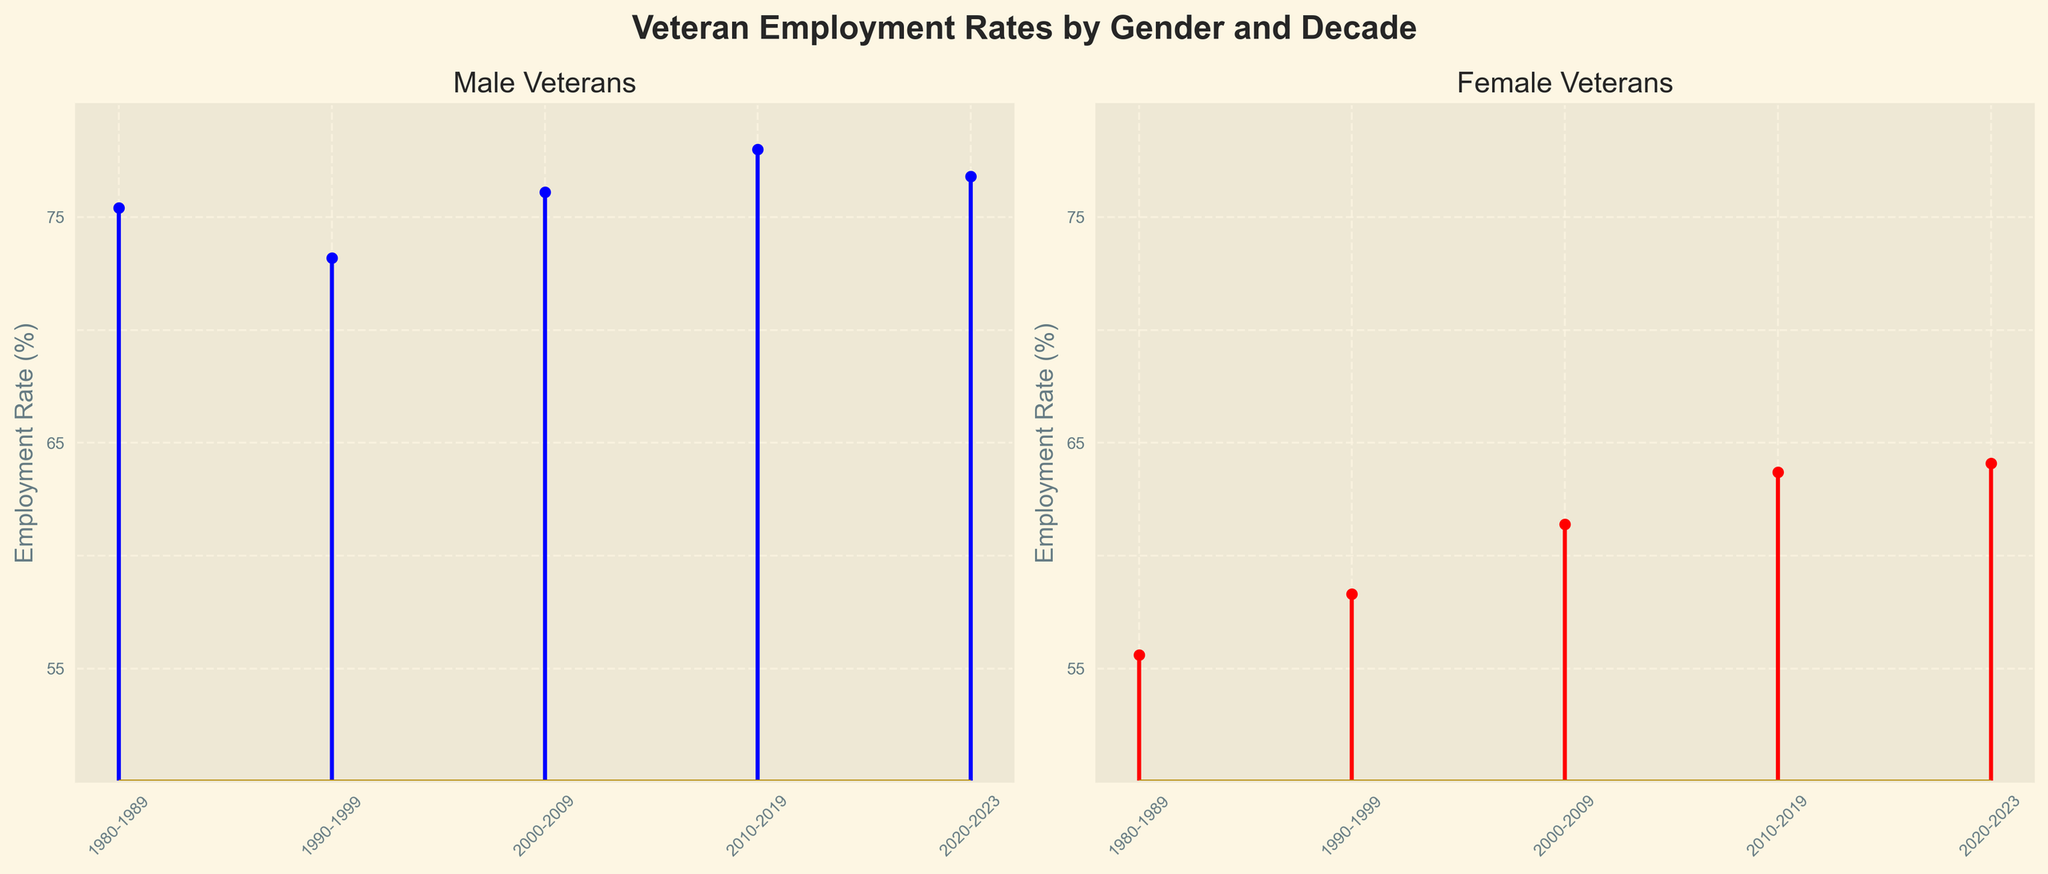What is the title of the figure? The title of the figure is written at the very top and provides a description of the figure.
Answer: Veteran Employment Rates by Gender and Decade What is the employment rate for male veterans in the 2000-2009 decade? Locate the stem plot for male veterans and identify the stem that corresponds to the 2000-2009 decade. The marker indicates the employment rate.
Answer: 76.1% Are female veterans' employment rates higher or lower in the 2020-2023 period compared to the 1980-1989 period? Compare the markers on the female veterans' stem plot for the periods 2020-2023 and 1980-1989.
Answer: Higher How has the employment rate for male veterans changed from the 1980-1989 period to the 2010-2019 period? Compare the employment rates for male veterans in the 1980-1989 period (75.4%) and the 2010-2019 period (78.0%). Calculate the difference.
Answer: Increased by 2.6% On average, which gender had a higher employment rate across all decades? Calculate the average employment rate for each gender by summing the rates for all decades and dividing by the number of decades. Compare the averages.
Answer: Male What is the difference in employment rates between male and female veterans in the 2010-2019 period? Locate the employment rates for male (78.0%) and female (63.7%) veterans for the 2010-2019 period. Subtract the female rate from the male rate.
Answer: 14.3% In which decade did female veterans see the greatest increase in their employment rate compared to the previous decade? Calculate the difference in employment rates for female veterans between each decade and identify the highest increase: 58.3% (1990-1999) - 55.6% (1980-1989), 61.4% (2000-2009) - 58.3% (1990-1999), 63.7% (2010-2019) - 61.4% (2000-2009), 64.1% (2020-2023) - 63.7% (2010-2019).
Answer: 1990-1999 to 2000-2009 Does the visualization show any trend in employment rates for female veterans over the decades? Observe the progression of markers in the stem plot for female veterans for a discernible trend over time.
Answer: Increasing trend What is the employment rate for female veterans in the 1980-1989 period? Locate the stem plot for female veterans and identify the marker that corresponds to the 1980-1989 decade.
Answer: 55.6% What is the purpose of the color coding in the figure? The colors differentiate between the employment rates for male (blue) and female (red) veterans, making it easier to compare them visually.
Answer: To differentiate gender-based employment rates 